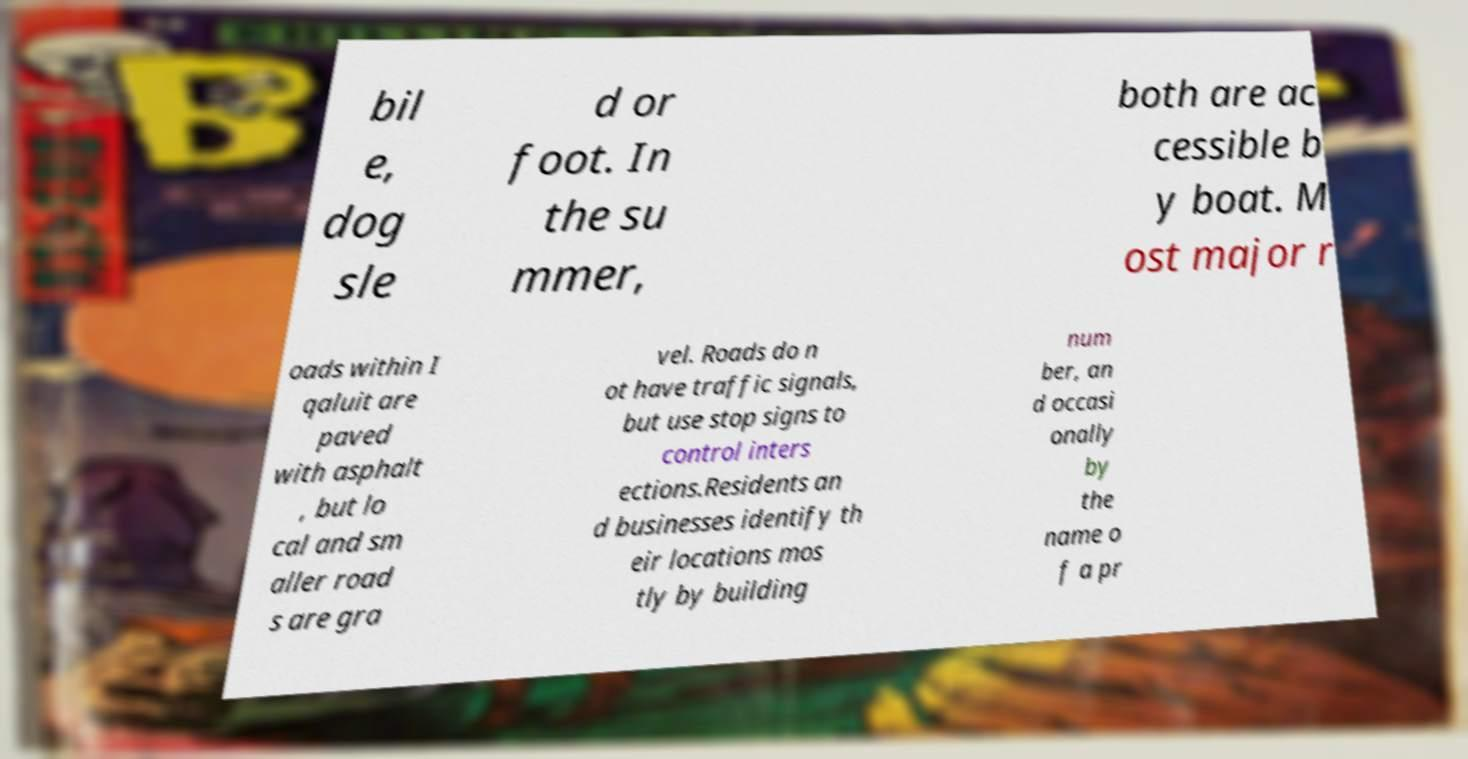Please read and relay the text visible in this image. What does it say? bil e, dog sle d or foot. In the su mmer, both are ac cessible b y boat. M ost major r oads within I qaluit are paved with asphalt , but lo cal and sm aller road s are gra vel. Roads do n ot have traffic signals, but use stop signs to control inters ections.Residents an d businesses identify th eir locations mos tly by building num ber, an d occasi onally by the name o f a pr 